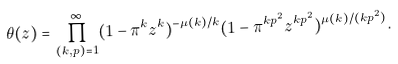<formula> <loc_0><loc_0><loc_500><loc_500>\theta ( z ) = \prod _ { ( k , p ) = 1 } ^ { \infty } ( 1 - \pi ^ { k } z ^ { k } ) ^ { - \mu ( k ) / k } ( 1 - \pi ^ { k p ^ { 2 } } z ^ { k p ^ { 2 } } ) ^ { \mu ( k ) / ( k p ^ { 2 } ) } .</formula> 